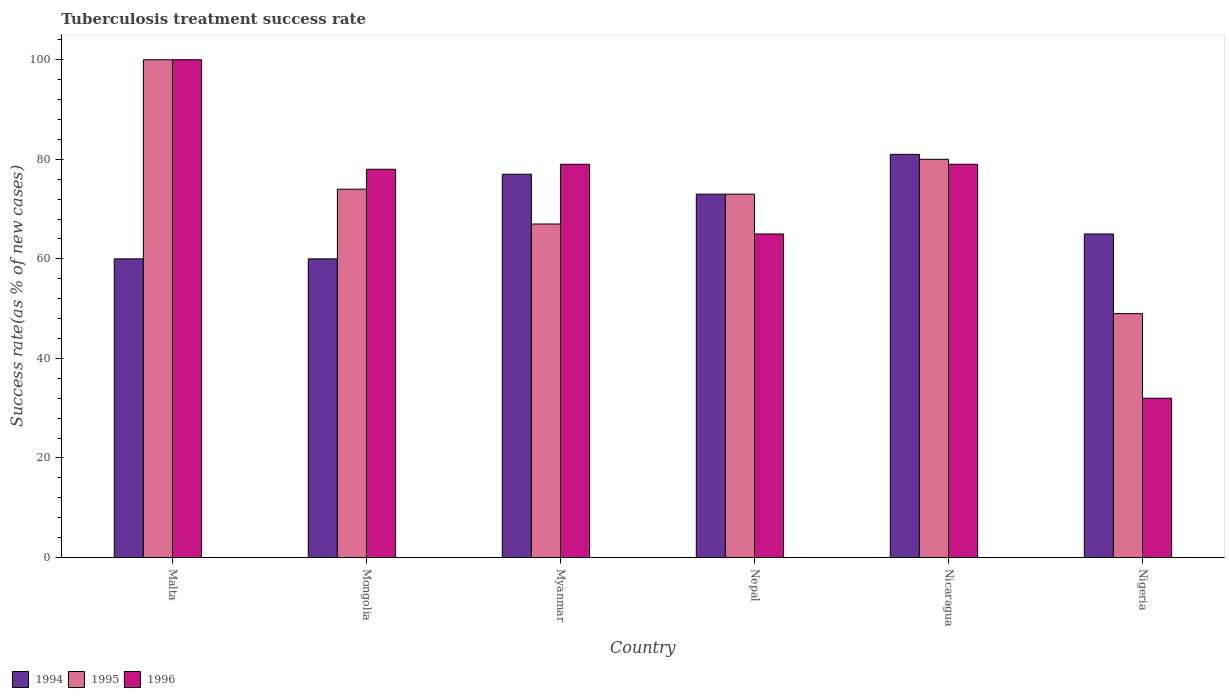Are the number of bars per tick equal to the number of legend labels?
Offer a terse response. Yes. How many bars are there on the 6th tick from the left?
Your answer should be very brief. 3. How many bars are there on the 6th tick from the right?
Offer a terse response. 3. What is the label of the 1st group of bars from the left?
Offer a terse response. Malta. In how many cases, is the number of bars for a given country not equal to the number of legend labels?
Provide a succinct answer. 0. What is the tuberculosis treatment success rate in 1995 in Mongolia?
Provide a succinct answer. 74. In which country was the tuberculosis treatment success rate in 1995 maximum?
Your answer should be very brief. Malta. In which country was the tuberculosis treatment success rate in 1996 minimum?
Your answer should be compact. Nigeria. What is the total tuberculosis treatment success rate in 1996 in the graph?
Provide a succinct answer. 433. What is the difference between the tuberculosis treatment success rate in 1995 in Malta and that in Nicaragua?
Your answer should be compact. 20. What is the average tuberculosis treatment success rate in 1996 per country?
Your answer should be very brief. 72.17. What is the difference between the tuberculosis treatment success rate of/in 1996 and tuberculosis treatment success rate of/in 1994 in Nigeria?
Offer a terse response. -33. What is the ratio of the tuberculosis treatment success rate in 1995 in Mongolia to that in Nicaragua?
Provide a succinct answer. 0.93. Is the difference between the tuberculosis treatment success rate in 1996 in Myanmar and Nepal greater than the difference between the tuberculosis treatment success rate in 1994 in Myanmar and Nepal?
Make the answer very short. Yes. What is the difference between the highest and the lowest tuberculosis treatment success rate in 1996?
Ensure brevity in your answer.  68. What does the 3rd bar from the left in Nicaragua represents?
Provide a short and direct response. 1996. What does the 2nd bar from the right in Nigeria represents?
Provide a short and direct response. 1995. Is it the case that in every country, the sum of the tuberculosis treatment success rate in 1995 and tuberculosis treatment success rate in 1994 is greater than the tuberculosis treatment success rate in 1996?
Your answer should be very brief. Yes. Are all the bars in the graph horizontal?
Make the answer very short. No. How many countries are there in the graph?
Keep it short and to the point. 6. What is the difference between two consecutive major ticks on the Y-axis?
Ensure brevity in your answer.  20. Does the graph contain any zero values?
Offer a terse response. No. How many legend labels are there?
Offer a terse response. 3. What is the title of the graph?
Make the answer very short. Tuberculosis treatment success rate. What is the label or title of the Y-axis?
Your answer should be compact. Success rate(as % of new cases). What is the Success rate(as % of new cases) of 1994 in Malta?
Your answer should be compact. 60. What is the Success rate(as % of new cases) in 1995 in Myanmar?
Offer a terse response. 67. What is the Success rate(as % of new cases) in 1996 in Myanmar?
Provide a succinct answer. 79. What is the Success rate(as % of new cases) in 1996 in Nepal?
Your answer should be compact. 65. What is the Success rate(as % of new cases) of 1994 in Nicaragua?
Offer a very short reply. 81. What is the Success rate(as % of new cases) in 1995 in Nicaragua?
Give a very brief answer. 80. What is the Success rate(as % of new cases) in 1996 in Nicaragua?
Provide a succinct answer. 79. What is the Success rate(as % of new cases) in 1994 in Nigeria?
Make the answer very short. 65. What is the Success rate(as % of new cases) of 1996 in Nigeria?
Provide a short and direct response. 32. Across all countries, what is the minimum Success rate(as % of new cases) in 1994?
Keep it short and to the point. 60. Across all countries, what is the minimum Success rate(as % of new cases) in 1995?
Offer a terse response. 49. Across all countries, what is the minimum Success rate(as % of new cases) of 1996?
Keep it short and to the point. 32. What is the total Success rate(as % of new cases) in 1994 in the graph?
Offer a terse response. 416. What is the total Success rate(as % of new cases) of 1995 in the graph?
Give a very brief answer. 443. What is the total Success rate(as % of new cases) in 1996 in the graph?
Provide a short and direct response. 433. What is the difference between the Success rate(as % of new cases) in 1995 in Malta and that in Mongolia?
Your answer should be compact. 26. What is the difference between the Success rate(as % of new cases) of 1994 in Malta and that in Myanmar?
Your answer should be very brief. -17. What is the difference between the Success rate(as % of new cases) in 1995 in Malta and that in Myanmar?
Offer a terse response. 33. What is the difference between the Success rate(as % of new cases) of 1996 in Malta and that in Myanmar?
Provide a succinct answer. 21. What is the difference between the Success rate(as % of new cases) of 1996 in Malta and that in Nigeria?
Ensure brevity in your answer.  68. What is the difference between the Success rate(as % of new cases) of 1996 in Mongolia and that in Myanmar?
Offer a very short reply. -1. What is the difference between the Success rate(as % of new cases) of 1994 in Mongolia and that in Nepal?
Provide a short and direct response. -13. What is the difference between the Success rate(as % of new cases) in 1994 in Mongolia and that in Nicaragua?
Give a very brief answer. -21. What is the difference between the Success rate(as % of new cases) in 1995 in Mongolia and that in Nicaragua?
Offer a very short reply. -6. What is the difference between the Success rate(as % of new cases) in 1995 in Mongolia and that in Nigeria?
Make the answer very short. 25. What is the difference between the Success rate(as % of new cases) in 1994 in Myanmar and that in Nepal?
Your answer should be very brief. 4. What is the difference between the Success rate(as % of new cases) in 1995 in Myanmar and that in Nepal?
Make the answer very short. -6. What is the difference between the Success rate(as % of new cases) in 1994 in Myanmar and that in Nicaragua?
Keep it short and to the point. -4. What is the difference between the Success rate(as % of new cases) in 1995 in Myanmar and that in Nigeria?
Provide a succinct answer. 18. What is the difference between the Success rate(as % of new cases) in 1994 in Nepal and that in Nicaragua?
Your response must be concise. -8. What is the difference between the Success rate(as % of new cases) in 1996 in Nepal and that in Nicaragua?
Make the answer very short. -14. What is the difference between the Success rate(as % of new cases) in 1994 in Nicaragua and that in Nigeria?
Keep it short and to the point. 16. What is the difference between the Success rate(as % of new cases) of 1996 in Nicaragua and that in Nigeria?
Offer a terse response. 47. What is the difference between the Success rate(as % of new cases) in 1994 in Malta and the Success rate(as % of new cases) in 1996 in Mongolia?
Keep it short and to the point. -18. What is the difference between the Success rate(as % of new cases) of 1995 in Malta and the Success rate(as % of new cases) of 1996 in Myanmar?
Give a very brief answer. 21. What is the difference between the Success rate(as % of new cases) of 1994 in Malta and the Success rate(as % of new cases) of 1996 in Nepal?
Provide a short and direct response. -5. What is the difference between the Success rate(as % of new cases) in 1995 in Malta and the Success rate(as % of new cases) in 1996 in Nepal?
Ensure brevity in your answer.  35. What is the difference between the Success rate(as % of new cases) of 1994 in Malta and the Success rate(as % of new cases) of 1995 in Nicaragua?
Provide a short and direct response. -20. What is the difference between the Success rate(as % of new cases) in 1994 in Malta and the Success rate(as % of new cases) in 1996 in Nicaragua?
Give a very brief answer. -19. What is the difference between the Success rate(as % of new cases) of 1995 in Malta and the Success rate(as % of new cases) of 1996 in Nicaragua?
Your answer should be compact. 21. What is the difference between the Success rate(as % of new cases) in 1994 in Malta and the Success rate(as % of new cases) in 1995 in Nigeria?
Give a very brief answer. 11. What is the difference between the Success rate(as % of new cases) of 1994 in Mongolia and the Success rate(as % of new cases) of 1996 in Myanmar?
Your answer should be very brief. -19. What is the difference between the Success rate(as % of new cases) of 1995 in Mongolia and the Success rate(as % of new cases) of 1996 in Nepal?
Make the answer very short. 9. What is the difference between the Success rate(as % of new cases) in 1994 in Mongolia and the Success rate(as % of new cases) in 1995 in Nicaragua?
Ensure brevity in your answer.  -20. What is the difference between the Success rate(as % of new cases) of 1995 in Mongolia and the Success rate(as % of new cases) of 1996 in Nicaragua?
Make the answer very short. -5. What is the difference between the Success rate(as % of new cases) in 1994 in Mongolia and the Success rate(as % of new cases) in 1995 in Nigeria?
Provide a short and direct response. 11. What is the difference between the Success rate(as % of new cases) of 1995 in Mongolia and the Success rate(as % of new cases) of 1996 in Nigeria?
Offer a very short reply. 42. What is the difference between the Success rate(as % of new cases) in 1995 in Myanmar and the Success rate(as % of new cases) in 1996 in Nepal?
Offer a terse response. 2. What is the difference between the Success rate(as % of new cases) of 1994 in Myanmar and the Success rate(as % of new cases) of 1995 in Nicaragua?
Ensure brevity in your answer.  -3. What is the difference between the Success rate(as % of new cases) in 1994 in Myanmar and the Success rate(as % of new cases) in 1996 in Nicaragua?
Keep it short and to the point. -2. What is the difference between the Success rate(as % of new cases) of 1995 in Myanmar and the Success rate(as % of new cases) of 1996 in Nicaragua?
Offer a terse response. -12. What is the difference between the Success rate(as % of new cases) in 1994 in Myanmar and the Success rate(as % of new cases) in 1995 in Nigeria?
Your answer should be compact. 28. What is the difference between the Success rate(as % of new cases) of 1994 in Myanmar and the Success rate(as % of new cases) of 1996 in Nigeria?
Offer a very short reply. 45. What is the difference between the Success rate(as % of new cases) in 1995 in Myanmar and the Success rate(as % of new cases) in 1996 in Nigeria?
Offer a terse response. 35. What is the difference between the Success rate(as % of new cases) of 1994 in Nepal and the Success rate(as % of new cases) of 1996 in Nicaragua?
Provide a short and direct response. -6. What is the difference between the Success rate(as % of new cases) of 1995 in Nepal and the Success rate(as % of new cases) of 1996 in Nicaragua?
Ensure brevity in your answer.  -6. What is the difference between the Success rate(as % of new cases) of 1994 in Nepal and the Success rate(as % of new cases) of 1995 in Nigeria?
Your answer should be very brief. 24. What is the difference between the Success rate(as % of new cases) of 1994 in Nepal and the Success rate(as % of new cases) of 1996 in Nigeria?
Your answer should be very brief. 41. What is the difference between the Success rate(as % of new cases) in 1995 in Nepal and the Success rate(as % of new cases) in 1996 in Nigeria?
Make the answer very short. 41. What is the difference between the Success rate(as % of new cases) in 1995 in Nicaragua and the Success rate(as % of new cases) in 1996 in Nigeria?
Your answer should be compact. 48. What is the average Success rate(as % of new cases) of 1994 per country?
Offer a very short reply. 69.33. What is the average Success rate(as % of new cases) of 1995 per country?
Offer a very short reply. 73.83. What is the average Success rate(as % of new cases) of 1996 per country?
Offer a very short reply. 72.17. What is the difference between the Success rate(as % of new cases) of 1994 and Success rate(as % of new cases) of 1996 in Malta?
Make the answer very short. -40. What is the difference between the Success rate(as % of new cases) of 1995 and Success rate(as % of new cases) of 1996 in Mongolia?
Offer a very short reply. -4. What is the difference between the Success rate(as % of new cases) of 1994 and Success rate(as % of new cases) of 1996 in Myanmar?
Give a very brief answer. -2. What is the difference between the Success rate(as % of new cases) of 1995 and Success rate(as % of new cases) of 1996 in Myanmar?
Provide a short and direct response. -12. What is the difference between the Success rate(as % of new cases) in 1994 and Success rate(as % of new cases) in 1995 in Nepal?
Provide a succinct answer. 0. What is the difference between the Success rate(as % of new cases) in 1994 and Success rate(as % of new cases) in 1995 in Nicaragua?
Give a very brief answer. 1. What is the difference between the Success rate(as % of new cases) of 1995 and Success rate(as % of new cases) of 1996 in Nicaragua?
Make the answer very short. 1. What is the ratio of the Success rate(as % of new cases) in 1994 in Malta to that in Mongolia?
Ensure brevity in your answer.  1. What is the ratio of the Success rate(as % of new cases) of 1995 in Malta to that in Mongolia?
Make the answer very short. 1.35. What is the ratio of the Success rate(as % of new cases) of 1996 in Malta to that in Mongolia?
Your answer should be very brief. 1.28. What is the ratio of the Success rate(as % of new cases) in 1994 in Malta to that in Myanmar?
Your answer should be very brief. 0.78. What is the ratio of the Success rate(as % of new cases) in 1995 in Malta to that in Myanmar?
Your response must be concise. 1.49. What is the ratio of the Success rate(as % of new cases) of 1996 in Malta to that in Myanmar?
Your answer should be very brief. 1.27. What is the ratio of the Success rate(as % of new cases) in 1994 in Malta to that in Nepal?
Keep it short and to the point. 0.82. What is the ratio of the Success rate(as % of new cases) of 1995 in Malta to that in Nepal?
Provide a short and direct response. 1.37. What is the ratio of the Success rate(as % of new cases) in 1996 in Malta to that in Nepal?
Your response must be concise. 1.54. What is the ratio of the Success rate(as % of new cases) in 1994 in Malta to that in Nicaragua?
Your response must be concise. 0.74. What is the ratio of the Success rate(as % of new cases) in 1995 in Malta to that in Nicaragua?
Offer a terse response. 1.25. What is the ratio of the Success rate(as % of new cases) in 1996 in Malta to that in Nicaragua?
Provide a short and direct response. 1.27. What is the ratio of the Success rate(as % of new cases) of 1995 in Malta to that in Nigeria?
Provide a short and direct response. 2.04. What is the ratio of the Success rate(as % of new cases) of 1996 in Malta to that in Nigeria?
Your response must be concise. 3.12. What is the ratio of the Success rate(as % of new cases) of 1994 in Mongolia to that in Myanmar?
Offer a very short reply. 0.78. What is the ratio of the Success rate(as % of new cases) of 1995 in Mongolia to that in Myanmar?
Your answer should be compact. 1.1. What is the ratio of the Success rate(as % of new cases) of 1996 in Mongolia to that in Myanmar?
Your response must be concise. 0.99. What is the ratio of the Success rate(as % of new cases) of 1994 in Mongolia to that in Nepal?
Your response must be concise. 0.82. What is the ratio of the Success rate(as % of new cases) of 1995 in Mongolia to that in Nepal?
Keep it short and to the point. 1.01. What is the ratio of the Success rate(as % of new cases) in 1994 in Mongolia to that in Nicaragua?
Give a very brief answer. 0.74. What is the ratio of the Success rate(as % of new cases) of 1995 in Mongolia to that in Nicaragua?
Keep it short and to the point. 0.93. What is the ratio of the Success rate(as % of new cases) of 1996 in Mongolia to that in Nicaragua?
Offer a very short reply. 0.99. What is the ratio of the Success rate(as % of new cases) in 1994 in Mongolia to that in Nigeria?
Give a very brief answer. 0.92. What is the ratio of the Success rate(as % of new cases) in 1995 in Mongolia to that in Nigeria?
Make the answer very short. 1.51. What is the ratio of the Success rate(as % of new cases) of 1996 in Mongolia to that in Nigeria?
Your answer should be compact. 2.44. What is the ratio of the Success rate(as % of new cases) in 1994 in Myanmar to that in Nepal?
Your answer should be compact. 1.05. What is the ratio of the Success rate(as % of new cases) of 1995 in Myanmar to that in Nepal?
Make the answer very short. 0.92. What is the ratio of the Success rate(as % of new cases) in 1996 in Myanmar to that in Nepal?
Your answer should be very brief. 1.22. What is the ratio of the Success rate(as % of new cases) in 1994 in Myanmar to that in Nicaragua?
Give a very brief answer. 0.95. What is the ratio of the Success rate(as % of new cases) in 1995 in Myanmar to that in Nicaragua?
Give a very brief answer. 0.84. What is the ratio of the Success rate(as % of new cases) of 1994 in Myanmar to that in Nigeria?
Give a very brief answer. 1.18. What is the ratio of the Success rate(as % of new cases) of 1995 in Myanmar to that in Nigeria?
Provide a succinct answer. 1.37. What is the ratio of the Success rate(as % of new cases) in 1996 in Myanmar to that in Nigeria?
Your answer should be very brief. 2.47. What is the ratio of the Success rate(as % of new cases) of 1994 in Nepal to that in Nicaragua?
Your answer should be very brief. 0.9. What is the ratio of the Success rate(as % of new cases) in 1995 in Nepal to that in Nicaragua?
Provide a short and direct response. 0.91. What is the ratio of the Success rate(as % of new cases) in 1996 in Nepal to that in Nicaragua?
Provide a short and direct response. 0.82. What is the ratio of the Success rate(as % of new cases) of 1994 in Nepal to that in Nigeria?
Your answer should be very brief. 1.12. What is the ratio of the Success rate(as % of new cases) of 1995 in Nepal to that in Nigeria?
Keep it short and to the point. 1.49. What is the ratio of the Success rate(as % of new cases) of 1996 in Nepal to that in Nigeria?
Keep it short and to the point. 2.03. What is the ratio of the Success rate(as % of new cases) in 1994 in Nicaragua to that in Nigeria?
Ensure brevity in your answer.  1.25. What is the ratio of the Success rate(as % of new cases) in 1995 in Nicaragua to that in Nigeria?
Provide a short and direct response. 1.63. What is the ratio of the Success rate(as % of new cases) of 1996 in Nicaragua to that in Nigeria?
Provide a succinct answer. 2.47. What is the difference between the highest and the second highest Success rate(as % of new cases) in 1994?
Your answer should be very brief. 4. What is the difference between the highest and the second highest Success rate(as % of new cases) of 1996?
Keep it short and to the point. 21. What is the difference between the highest and the lowest Success rate(as % of new cases) of 1994?
Offer a very short reply. 21. What is the difference between the highest and the lowest Success rate(as % of new cases) of 1995?
Keep it short and to the point. 51. 